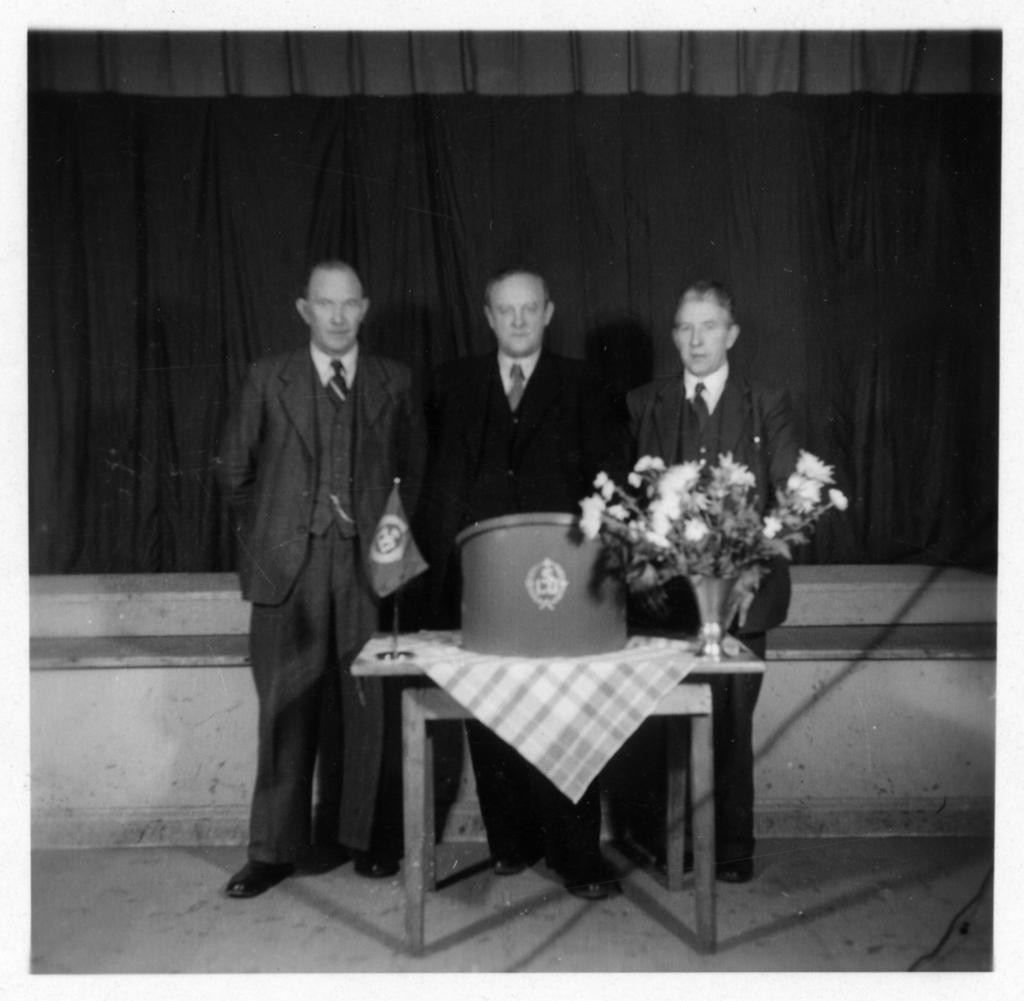Can you describe this image briefly? A black and white picture. This 3 persons are standing. In-front of them there is a table, on a table there is a cloth, flag and flowers. 